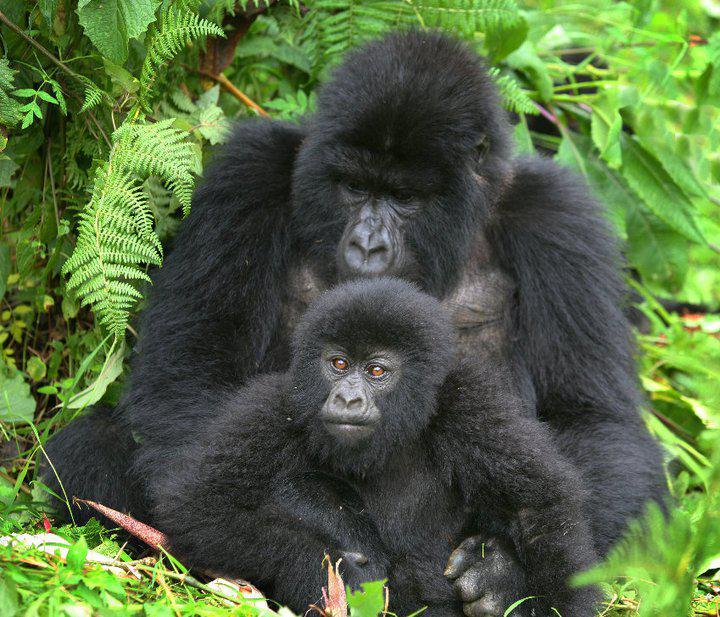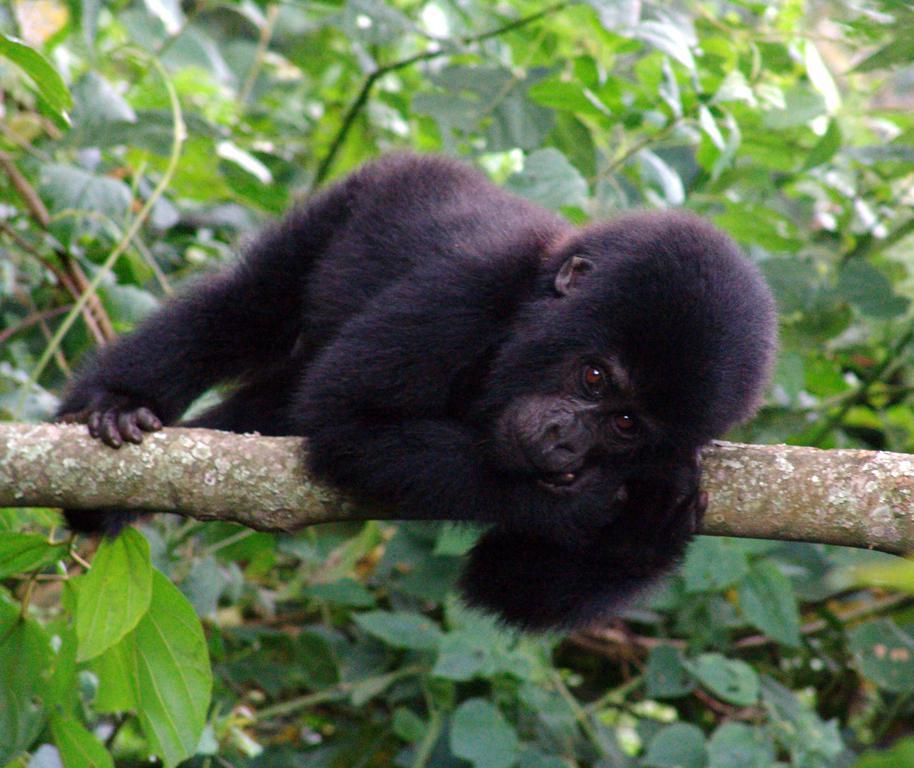The first image is the image on the left, the second image is the image on the right. Considering the images on both sides, is "The left image contains exactly two gorillas." valid? Answer yes or no. Yes. The first image is the image on the left, the second image is the image on the right. Examine the images to the left and right. Is the description "There is a gorilla holding another gorilla from the back in one of the images." accurate? Answer yes or no. Yes. The first image is the image on the left, the second image is the image on the right. Assess this claim about the two images: "There are exactly three animals outside.". Correct or not? Answer yes or no. Yes. The first image is the image on the left, the second image is the image on the right. For the images displayed, is the sentence "At least one image contains a single adult male gorilla, who is walking in a bent over pose and eyeing the camera." factually correct? Answer yes or no. No. 